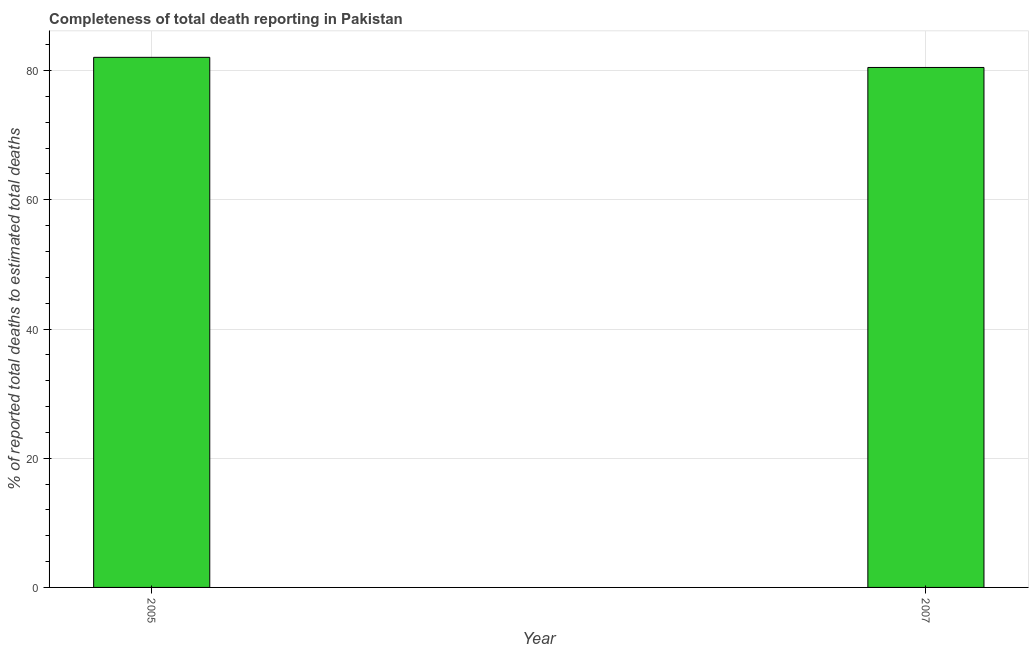Does the graph contain any zero values?
Keep it short and to the point. No. What is the title of the graph?
Offer a very short reply. Completeness of total death reporting in Pakistan. What is the label or title of the X-axis?
Make the answer very short. Year. What is the label or title of the Y-axis?
Keep it short and to the point. % of reported total deaths to estimated total deaths. What is the completeness of total death reports in 2005?
Give a very brief answer. 82.05. Across all years, what is the maximum completeness of total death reports?
Provide a succinct answer. 82.05. Across all years, what is the minimum completeness of total death reports?
Ensure brevity in your answer.  80.48. In which year was the completeness of total death reports maximum?
Your answer should be very brief. 2005. What is the sum of the completeness of total death reports?
Provide a succinct answer. 162.53. What is the difference between the completeness of total death reports in 2005 and 2007?
Your answer should be compact. 1.57. What is the average completeness of total death reports per year?
Your response must be concise. 81.27. What is the median completeness of total death reports?
Give a very brief answer. 81.27. In how many years, is the completeness of total death reports greater than 36 %?
Your answer should be compact. 2. Do a majority of the years between 2007 and 2005 (inclusive) have completeness of total death reports greater than 4 %?
Your answer should be very brief. No. In how many years, is the completeness of total death reports greater than the average completeness of total death reports taken over all years?
Ensure brevity in your answer.  1. How many bars are there?
Make the answer very short. 2. Are all the bars in the graph horizontal?
Make the answer very short. No. How many years are there in the graph?
Provide a succinct answer. 2. What is the % of reported total deaths to estimated total deaths of 2005?
Your answer should be very brief. 82.05. What is the % of reported total deaths to estimated total deaths of 2007?
Ensure brevity in your answer.  80.48. What is the difference between the % of reported total deaths to estimated total deaths in 2005 and 2007?
Give a very brief answer. 1.57. What is the ratio of the % of reported total deaths to estimated total deaths in 2005 to that in 2007?
Provide a succinct answer. 1.02. 